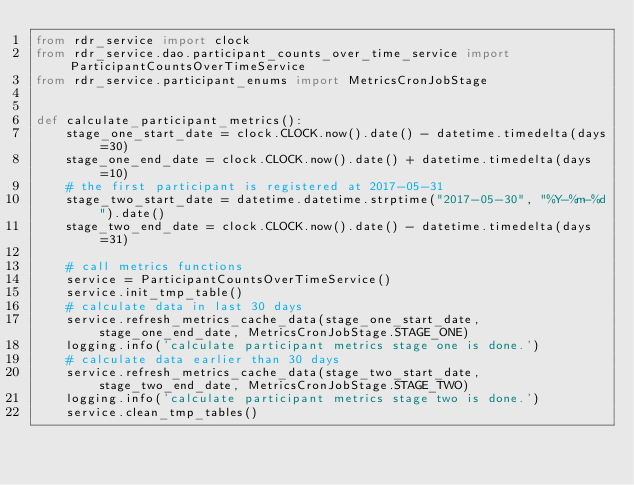Convert code to text. <code><loc_0><loc_0><loc_500><loc_500><_Python_>from rdr_service import clock
from rdr_service.dao.participant_counts_over_time_service import ParticipantCountsOverTimeService
from rdr_service.participant_enums import MetricsCronJobStage


def calculate_participant_metrics():
    stage_one_start_date = clock.CLOCK.now().date() - datetime.timedelta(days=30)
    stage_one_end_date = clock.CLOCK.now().date() + datetime.timedelta(days=10)
    # the first participant is registered at 2017-05-31
    stage_two_start_date = datetime.datetime.strptime("2017-05-30", "%Y-%m-%d").date()
    stage_two_end_date = clock.CLOCK.now().date() - datetime.timedelta(days=31)

    # call metrics functions
    service = ParticipantCountsOverTimeService()
    service.init_tmp_table()
    # calculate data in last 30 days
    service.refresh_metrics_cache_data(stage_one_start_date, stage_one_end_date, MetricsCronJobStage.STAGE_ONE)
    logging.info('calculate participant metrics stage one is done.')
    # calculate data earlier than 30 days
    service.refresh_metrics_cache_data(stage_two_start_date, stage_two_end_date, MetricsCronJobStage.STAGE_TWO)
    logging.info('calculate participant metrics stage two is done.')
    service.clean_tmp_tables()
</code> 